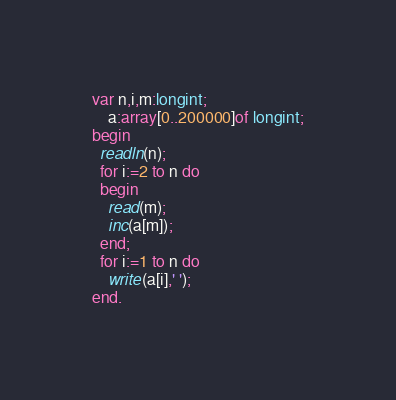Convert code to text. <code><loc_0><loc_0><loc_500><loc_500><_Pascal_>var n,i,m:longint;
    a:array[0..200000]of longint;
begin
  readln(n);
  for i:=2 to n do
  begin
    read(m);
    inc(a[m]);
  end;
  for i:=1 to n do
    write(a[i],' ');
end.</code> 